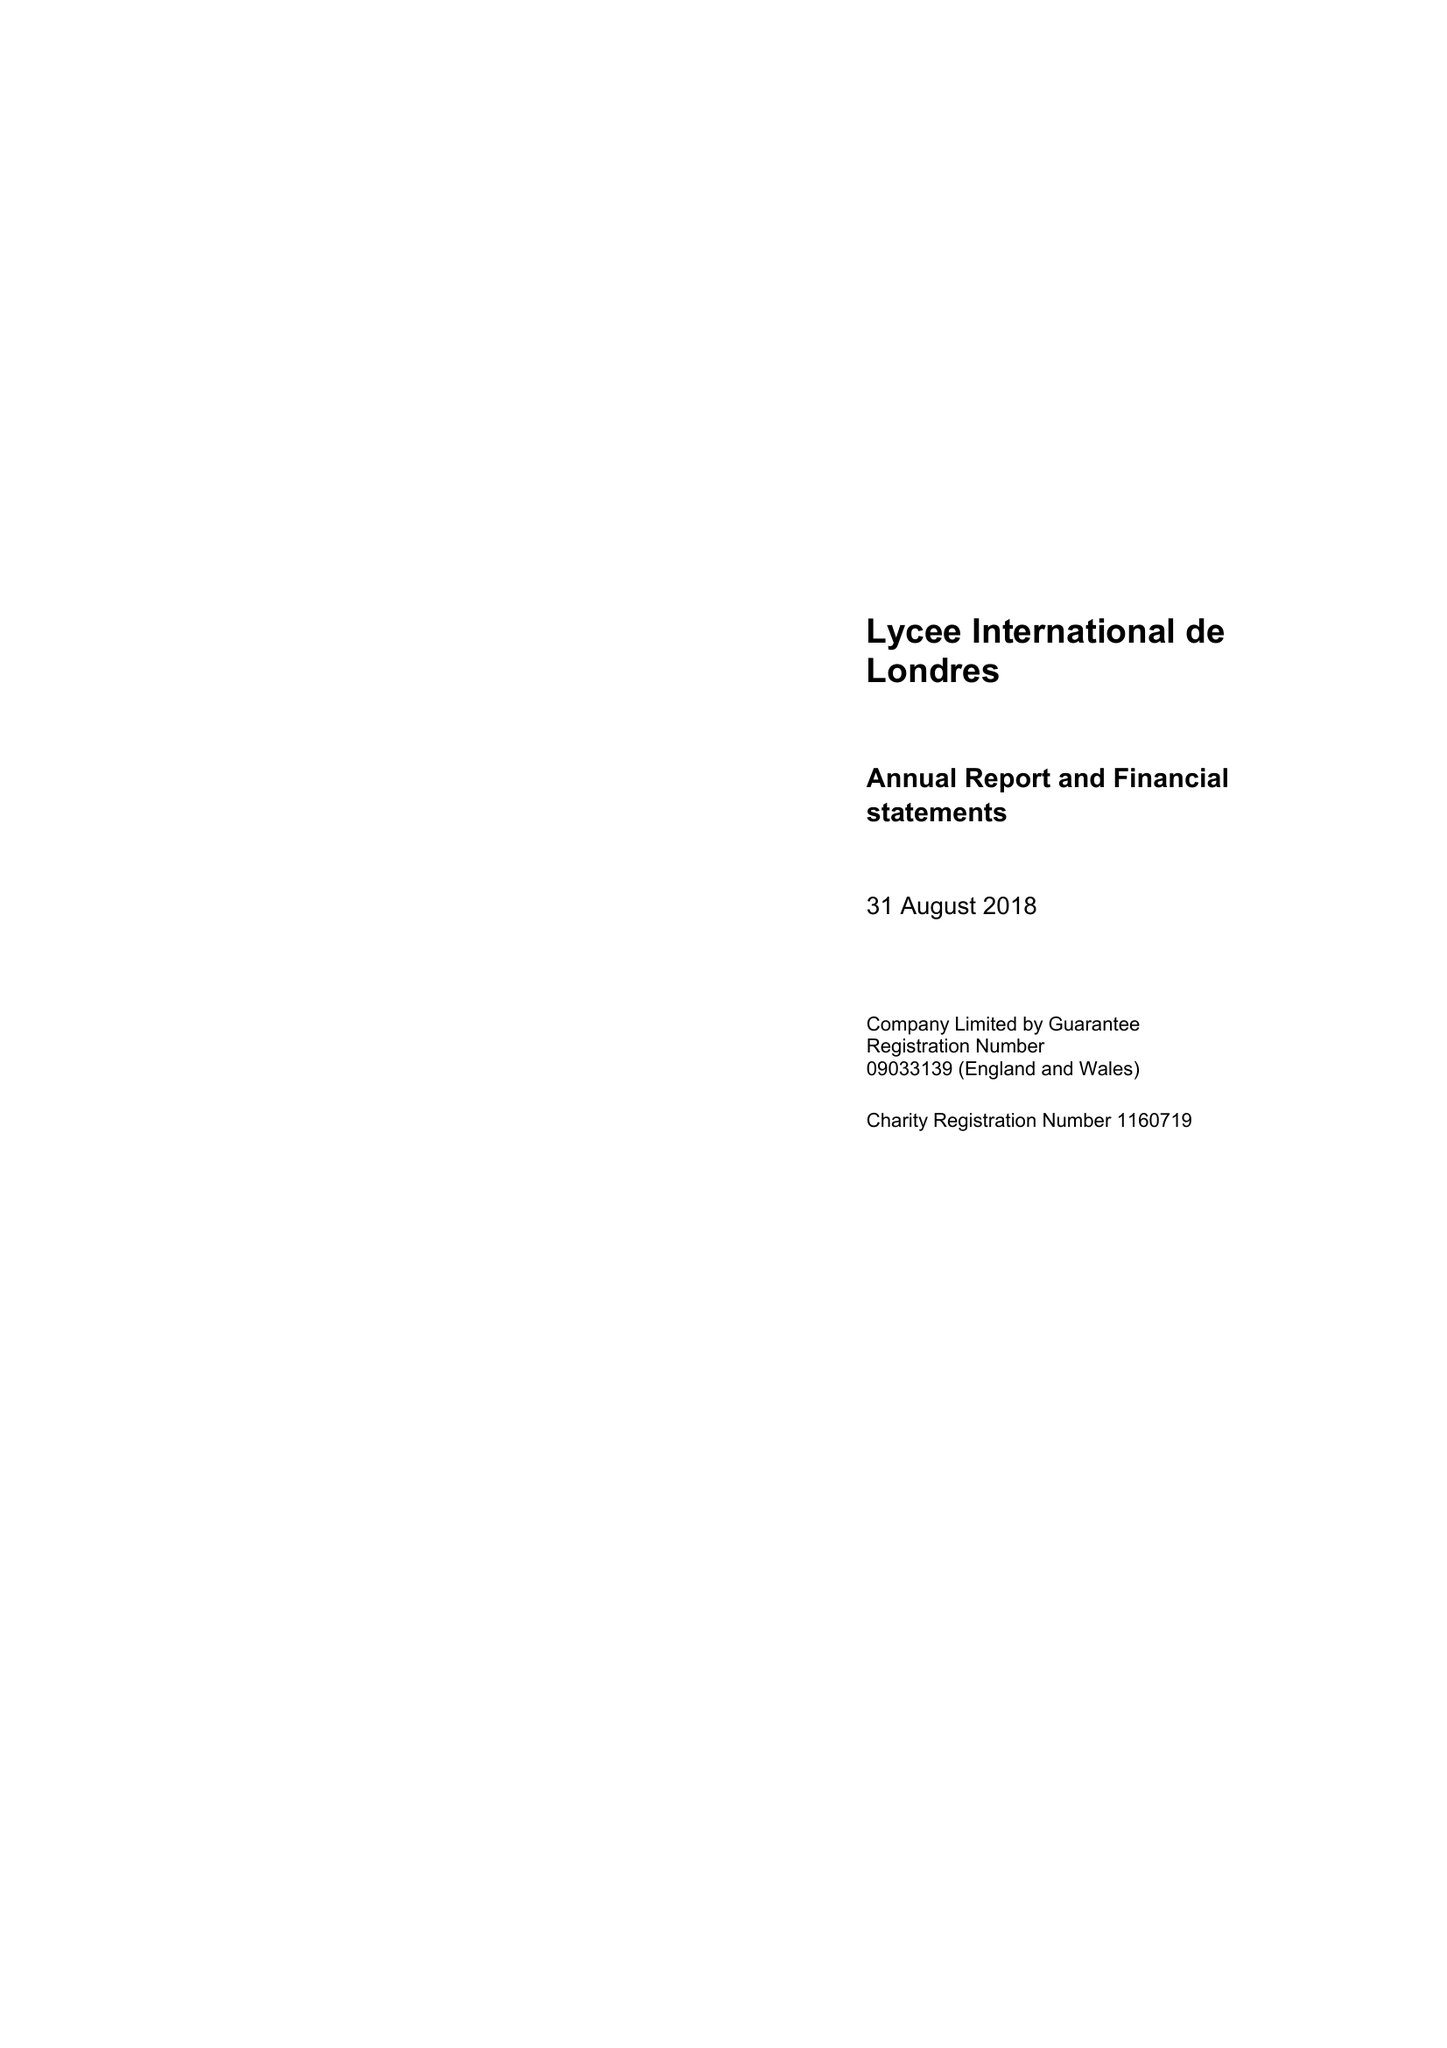What is the value for the address__postcode?
Answer the question using a single word or phrase. HA9 9LY 